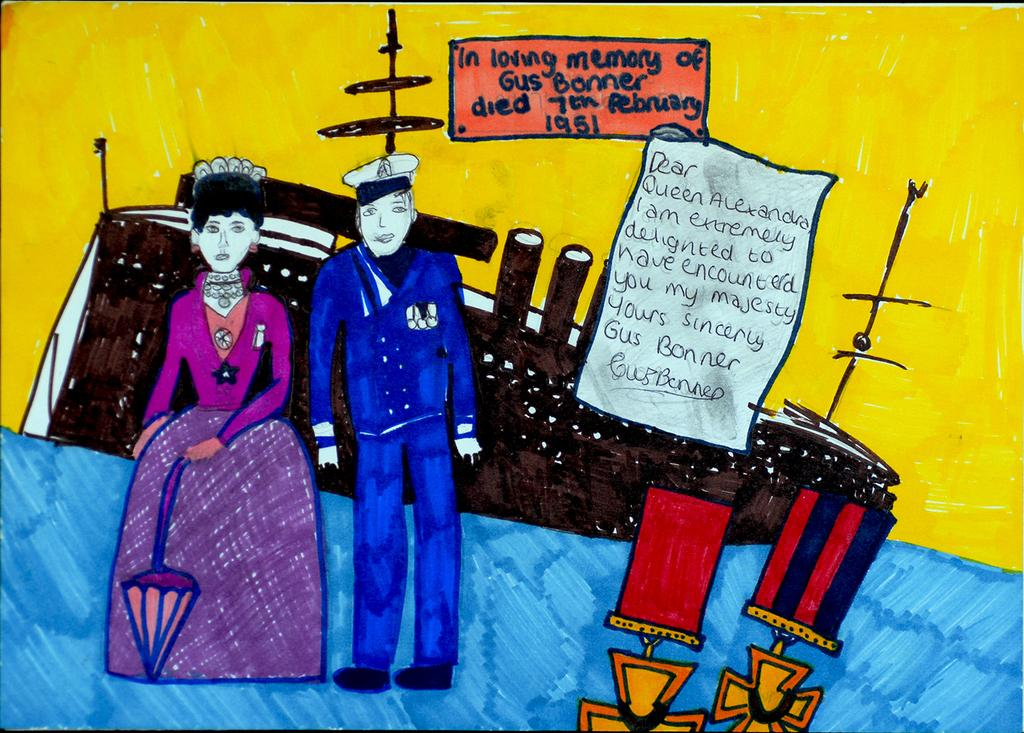How many people are present in the image? There are two people standing in the image. What can be seen in the background of the image? There is a boat visible in the background. What type of objects can be seen with writing on them in the image? There are papers with writing on them in the image. Can you describe the color scheme of the objects in the image? The objects in the image have colors, but the background has a blue and yellow color scheme. What type of clouds can be seen in the image? There are no clouds visible in the image; it features two people standing and a boat in the background. What is the texture of the board in the image? There is no board present in the image. 